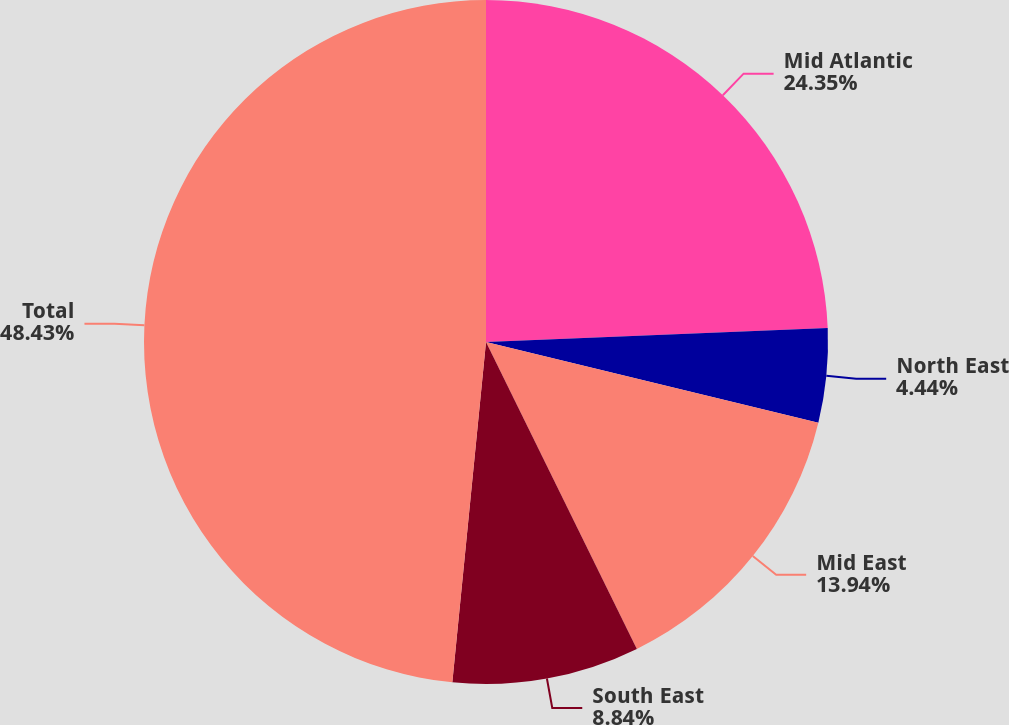<chart> <loc_0><loc_0><loc_500><loc_500><pie_chart><fcel>Mid Atlantic<fcel>North East<fcel>Mid East<fcel>South East<fcel>Total<nl><fcel>24.35%<fcel>4.44%<fcel>13.94%<fcel>8.84%<fcel>48.43%<nl></chart> 